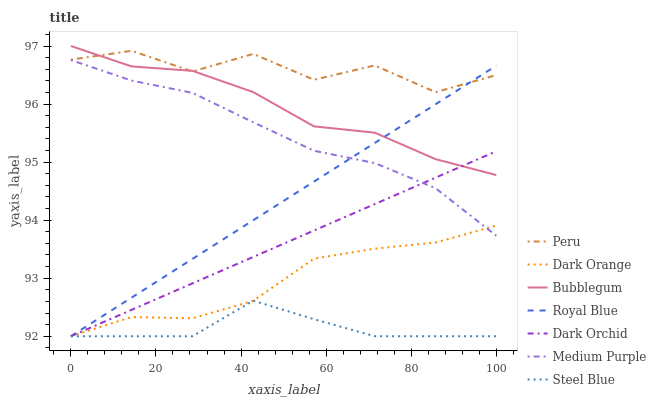Does Steel Blue have the minimum area under the curve?
Answer yes or no. Yes. Does Peru have the maximum area under the curve?
Answer yes or no. Yes. Does Dark Orchid have the minimum area under the curve?
Answer yes or no. No. Does Dark Orchid have the maximum area under the curve?
Answer yes or no. No. Is Dark Orchid the smoothest?
Answer yes or no. Yes. Is Peru the roughest?
Answer yes or no. Yes. Is Steel Blue the smoothest?
Answer yes or no. No. Is Steel Blue the roughest?
Answer yes or no. No. Does Dark Orange have the lowest value?
Answer yes or no. Yes. Does Medium Purple have the lowest value?
Answer yes or no. No. Does Bubblegum have the highest value?
Answer yes or no. Yes. Does Dark Orchid have the highest value?
Answer yes or no. No. Is Dark Orange less than Peru?
Answer yes or no. Yes. Is Bubblegum greater than Steel Blue?
Answer yes or no. Yes. Does Dark Orchid intersect Steel Blue?
Answer yes or no. Yes. Is Dark Orchid less than Steel Blue?
Answer yes or no. No. Is Dark Orchid greater than Steel Blue?
Answer yes or no. No. Does Dark Orange intersect Peru?
Answer yes or no. No. 